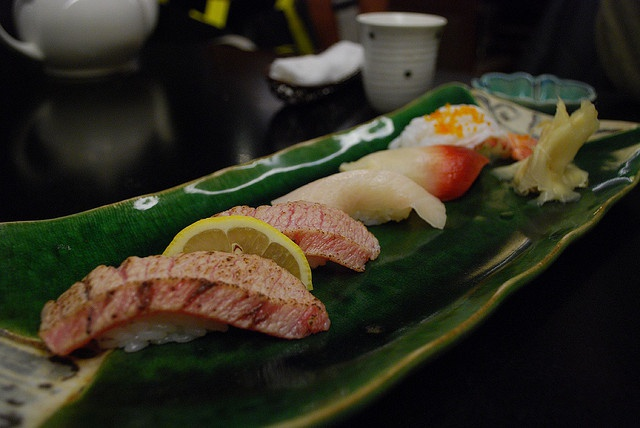Describe the objects in this image and their specific colors. I can see dining table in black, gray, and darkgreen tones, cake in black, gray, maroon, and tan tones, cup in black, gray, and darkgray tones, and bowl in black, teal, gray, and darkgreen tones in this image. 